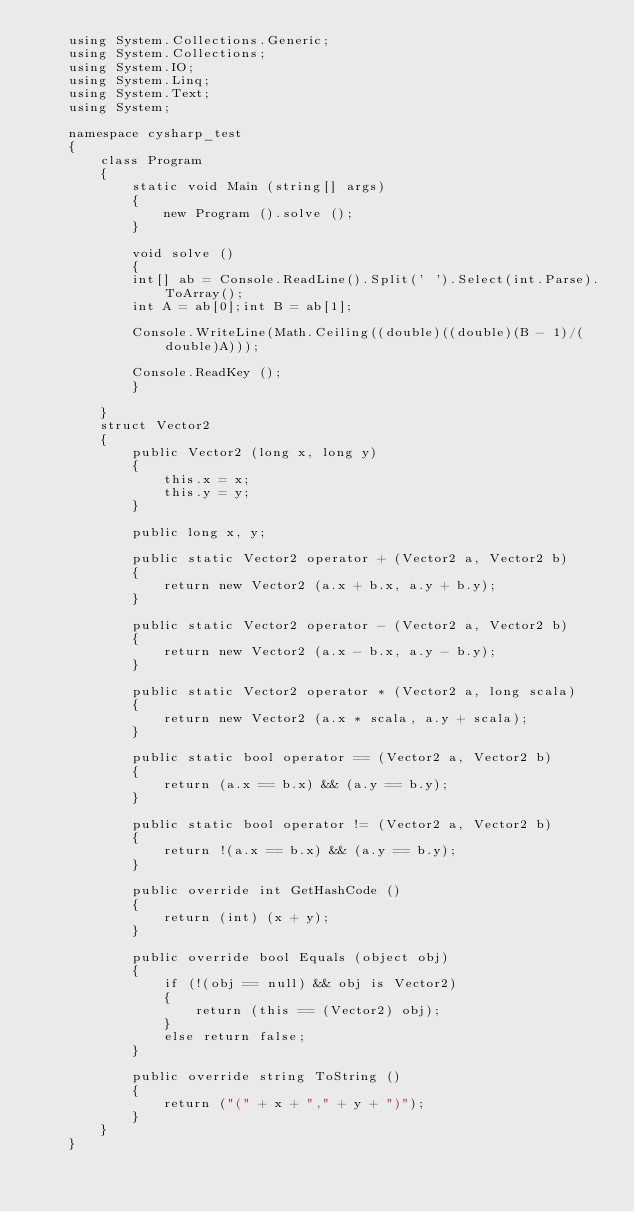Convert code to text. <code><loc_0><loc_0><loc_500><loc_500><_C#_>    using System.Collections.Generic;
    using System.Collections;
    using System.IO;
    using System.Linq;
    using System.Text;
    using System;

    namespace cysharp_test
    {
        class Program
        {
            static void Main (string[] args)
            {
                new Program ().solve ();
            }

            void solve ()
            {
            int[] ab = Console.ReadLine().Split(' ').Select(int.Parse).ToArray();
            int A = ab[0];int B = ab[1];

            Console.WriteLine(Math.Ceiling((double)((double)(B - 1)/(double)A)));

            Console.ReadKey ();
            }

        }
        struct Vector2
        {
            public Vector2 (long x, long y)
            {
                this.x = x;
                this.y = y;
            }

            public long x, y;

            public static Vector2 operator + (Vector2 a, Vector2 b)
            {
                return new Vector2 (a.x + b.x, a.y + b.y);
            }

            public static Vector2 operator - (Vector2 a, Vector2 b)
            {
                return new Vector2 (a.x - b.x, a.y - b.y);
            }

            public static Vector2 operator * (Vector2 a, long scala)
            {
                return new Vector2 (a.x * scala, a.y + scala);
            }

            public static bool operator == (Vector2 a, Vector2 b)
            {
                return (a.x == b.x) && (a.y == b.y);
            }

            public static bool operator != (Vector2 a, Vector2 b)
            {
                return !(a.x == b.x) && (a.y == b.y);
            }

            public override int GetHashCode ()
            {
                return (int) (x + y);
            }

            public override bool Equals (object obj)
            {
                if (!(obj == null) && obj is Vector2)
                {
                    return (this == (Vector2) obj);
                }
                else return false;
            }

            public override string ToString ()
            {
                return ("(" + x + "," + y + ")");
            }
        }
    }</code> 